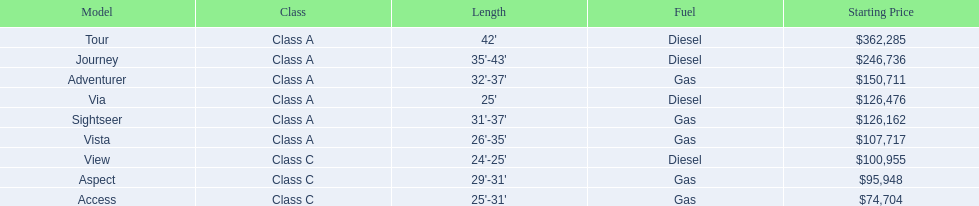Is the vista more than the aspect? Yes. 